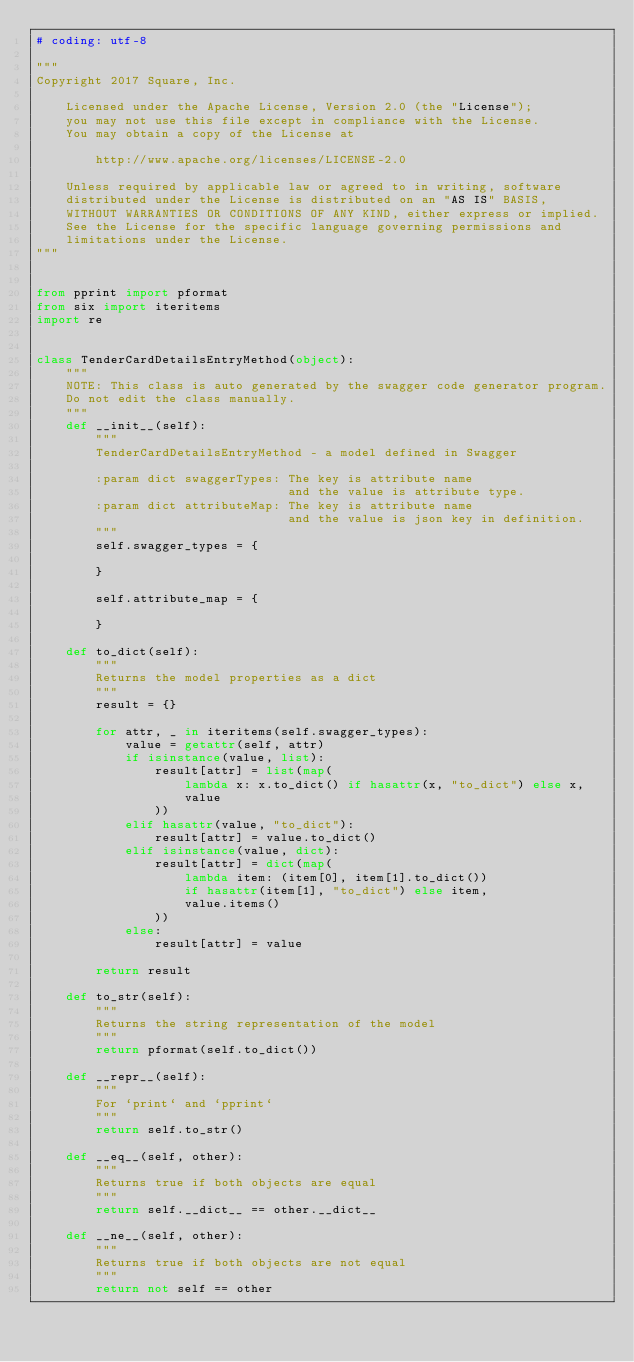<code> <loc_0><loc_0><loc_500><loc_500><_Python_># coding: utf-8

"""
Copyright 2017 Square, Inc.

    Licensed under the Apache License, Version 2.0 (the "License");
    you may not use this file except in compliance with the License.
    You may obtain a copy of the License at

        http://www.apache.org/licenses/LICENSE-2.0

    Unless required by applicable law or agreed to in writing, software
    distributed under the License is distributed on an "AS IS" BASIS,
    WITHOUT WARRANTIES OR CONDITIONS OF ANY KIND, either express or implied.
    See the License for the specific language governing permissions and
    limitations under the License.
"""


from pprint import pformat
from six import iteritems
import re


class TenderCardDetailsEntryMethod(object):
    """
    NOTE: This class is auto generated by the swagger code generator program.
    Do not edit the class manually.
    """
    def __init__(self):
        """
        TenderCardDetailsEntryMethod - a model defined in Swagger

        :param dict swaggerTypes: The key is attribute name
                                  and the value is attribute type.
        :param dict attributeMap: The key is attribute name
                                  and the value is json key in definition.
        """
        self.swagger_types = {
            
        }

        self.attribute_map = {
            
        }

    def to_dict(self):
        """
        Returns the model properties as a dict
        """
        result = {}

        for attr, _ in iteritems(self.swagger_types):
            value = getattr(self, attr)
            if isinstance(value, list):
                result[attr] = list(map(
                    lambda x: x.to_dict() if hasattr(x, "to_dict") else x,
                    value
                ))
            elif hasattr(value, "to_dict"):
                result[attr] = value.to_dict()
            elif isinstance(value, dict):
                result[attr] = dict(map(
                    lambda item: (item[0], item[1].to_dict())
                    if hasattr(item[1], "to_dict") else item,
                    value.items()
                ))
            else:
                result[attr] = value

        return result

    def to_str(self):
        """
        Returns the string representation of the model
        """
        return pformat(self.to_dict())

    def __repr__(self):
        """
        For `print` and `pprint`
        """
        return self.to_str()

    def __eq__(self, other):
        """
        Returns true if both objects are equal
        """
        return self.__dict__ == other.__dict__

    def __ne__(self, other):
        """
        Returns true if both objects are not equal
        """
        return not self == other
</code> 